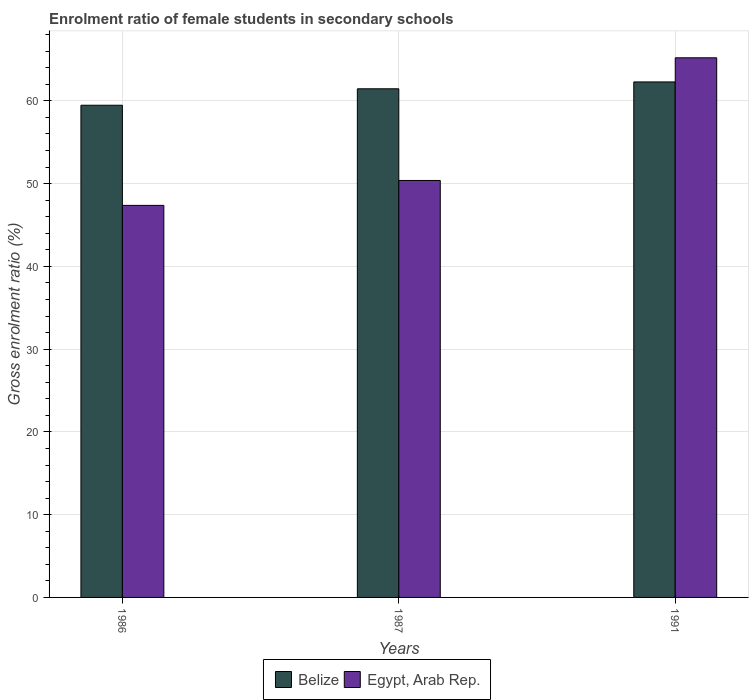How many groups of bars are there?
Ensure brevity in your answer.  3. Are the number of bars on each tick of the X-axis equal?
Provide a succinct answer. Yes. How many bars are there on the 2nd tick from the left?
Offer a terse response. 2. What is the label of the 2nd group of bars from the left?
Ensure brevity in your answer.  1987. What is the enrolment ratio of female students in secondary schools in Egypt, Arab Rep. in 1986?
Offer a very short reply. 47.37. Across all years, what is the maximum enrolment ratio of female students in secondary schools in Egypt, Arab Rep.?
Make the answer very short. 65.2. Across all years, what is the minimum enrolment ratio of female students in secondary schools in Egypt, Arab Rep.?
Offer a terse response. 47.37. In which year was the enrolment ratio of female students in secondary schools in Belize minimum?
Offer a terse response. 1986. What is the total enrolment ratio of female students in secondary schools in Belize in the graph?
Your answer should be very brief. 183.22. What is the difference between the enrolment ratio of female students in secondary schools in Belize in 1986 and that in 1991?
Provide a succinct answer. -2.82. What is the difference between the enrolment ratio of female students in secondary schools in Egypt, Arab Rep. in 1987 and the enrolment ratio of female students in secondary schools in Belize in 1991?
Offer a terse response. -11.91. What is the average enrolment ratio of female students in secondary schools in Egypt, Arab Rep. per year?
Your answer should be very brief. 54.32. In the year 1986, what is the difference between the enrolment ratio of female students in secondary schools in Egypt, Arab Rep. and enrolment ratio of female students in secondary schools in Belize?
Your answer should be compact. -12.1. What is the ratio of the enrolment ratio of female students in secondary schools in Egypt, Arab Rep. in 1986 to that in 1991?
Offer a terse response. 0.73. Is the enrolment ratio of female students in secondary schools in Belize in 1986 less than that in 1987?
Offer a very short reply. Yes. What is the difference between the highest and the second highest enrolment ratio of female students in secondary schools in Belize?
Offer a very short reply. 0.83. What is the difference between the highest and the lowest enrolment ratio of female students in secondary schools in Egypt, Arab Rep.?
Your answer should be very brief. 17.83. What does the 2nd bar from the left in 1987 represents?
Your answer should be very brief. Egypt, Arab Rep. What does the 2nd bar from the right in 1987 represents?
Your response must be concise. Belize. How many bars are there?
Provide a short and direct response. 6. Are all the bars in the graph horizontal?
Provide a short and direct response. No. How many years are there in the graph?
Your response must be concise. 3. What is the difference between two consecutive major ticks on the Y-axis?
Your answer should be very brief. 10. Does the graph contain any zero values?
Your answer should be compact. No. How many legend labels are there?
Offer a very short reply. 2. What is the title of the graph?
Provide a succinct answer. Enrolment ratio of female students in secondary schools. What is the Gross enrolment ratio (%) of Belize in 1986?
Keep it short and to the point. 59.47. What is the Gross enrolment ratio (%) of Egypt, Arab Rep. in 1986?
Provide a succinct answer. 47.37. What is the Gross enrolment ratio (%) in Belize in 1987?
Keep it short and to the point. 61.46. What is the Gross enrolment ratio (%) in Egypt, Arab Rep. in 1987?
Your answer should be very brief. 50.38. What is the Gross enrolment ratio (%) in Belize in 1991?
Provide a short and direct response. 62.29. What is the Gross enrolment ratio (%) in Egypt, Arab Rep. in 1991?
Keep it short and to the point. 65.2. Across all years, what is the maximum Gross enrolment ratio (%) of Belize?
Keep it short and to the point. 62.29. Across all years, what is the maximum Gross enrolment ratio (%) in Egypt, Arab Rep.?
Provide a succinct answer. 65.2. Across all years, what is the minimum Gross enrolment ratio (%) in Belize?
Make the answer very short. 59.47. Across all years, what is the minimum Gross enrolment ratio (%) in Egypt, Arab Rep.?
Your response must be concise. 47.37. What is the total Gross enrolment ratio (%) in Belize in the graph?
Your response must be concise. 183.22. What is the total Gross enrolment ratio (%) of Egypt, Arab Rep. in the graph?
Offer a terse response. 162.95. What is the difference between the Gross enrolment ratio (%) in Belize in 1986 and that in 1987?
Offer a terse response. -1.99. What is the difference between the Gross enrolment ratio (%) of Egypt, Arab Rep. in 1986 and that in 1987?
Offer a very short reply. -3.01. What is the difference between the Gross enrolment ratio (%) in Belize in 1986 and that in 1991?
Your response must be concise. -2.82. What is the difference between the Gross enrolment ratio (%) in Egypt, Arab Rep. in 1986 and that in 1991?
Offer a terse response. -17.83. What is the difference between the Gross enrolment ratio (%) of Belize in 1987 and that in 1991?
Your answer should be very brief. -0.83. What is the difference between the Gross enrolment ratio (%) in Egypt, Arab Rep. in 1987 and that in 1991?
Your answer should be very brief. -14.82. What is the difference between the Gross enrolment ratio (%) of Belize in 1986 and the Gross enrolment ratio (%) of Egypt, Arab Rep. in 1987?
Ensure brevity in your answer.  9.09. What is the difference between the Gross enrolment ratio (%) of Belize in 1986 and the Gross enrolment ratio (%) of Egypt, Arab Rep. in 1991?
Your response must be concise. -5.73. What is the difference between the Gross enrolment ratio (%) of Belize in 1987 and the Gross enrolment ratio (%) of Egypt, Arab Rep. in 1991?
Offer a very short reply. -3.74. What is the average Gross enrolment ratio (%) in Belize per year?
Your answer should be compact. 61.07. What is the average Gross enrolment ratio (%) in Egypt, Arab Rep. per year?
Give a very brief answer. 54.32. In the year 1986, what is the difference between the Gross enrolment ratio (%) of Belize and Gross enrolment ratio (%) of Egypt, Arab Rep.?
Offer a terse response. 12.1. In the year 1987, what is the difference between the Gross enrolment ratio (%) of Belize and Gross enrolment ratio (%) of Egypt, Arab Rep.?
Provide a short and direct response. 11.08. In the year 1991, what is the difference between the Gross enrolment ratio (%) of Belize and Gross enrolment ratio (%) of Egypt, Arab Rep.?
Offer a terse response. -2.91. What is the ratio of the Gross enrolment ratio (%) in Egypt, Arab Rep. in 1986 to that in 1987?
Provide a succinct answer. 0.94. What is the ratio of the Gross enrolment ratio (%) in Belize in 1986 to that in 1991?
Offer a terse response. 0.95. What is the ratio of the Gross enrolment ratio (%) of Egypt, Arab Rep. in 1986 to that in 1991?
Your answer should be compact. 0.73. What is the ratio of the Gross enrolment ratio (%) of Belize in 1987 to that in 1991?
Ensure brevity in your answer.  0.99. What is the ratio of the Gross enrolment ratio (%) of Egypt, Arab Rep. in 1987 to that in 1991?
Keep it short and to the point. 0.77. What is the difference between the highest and the second highest Gross enrolment ratio (%) in Belize?
Keep it short and to the point. 0.83. What is the difference between the highest and the second highest Gross enrolment ratio (%) of Egypt, Arab Rep.?
Your response must be concise. 14.82. What is the difference between the highest and the lowest Gross enrolment ratio (%) of Belize?
Ensure brevity in your answer.  2.82. What is the difference between the highest and the lowest Gross enrolment ratio (%) of Egypt, Arab Rep.?
Your answer should be compact. 17.83. 